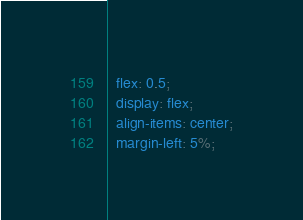Convert code to text. <code><loc_0><loc_0><loc_500><loc_500><_CSS_>  flex: 0.5;
  display: flex;
  align-items: center;
  margin-left: 5%;</code> 